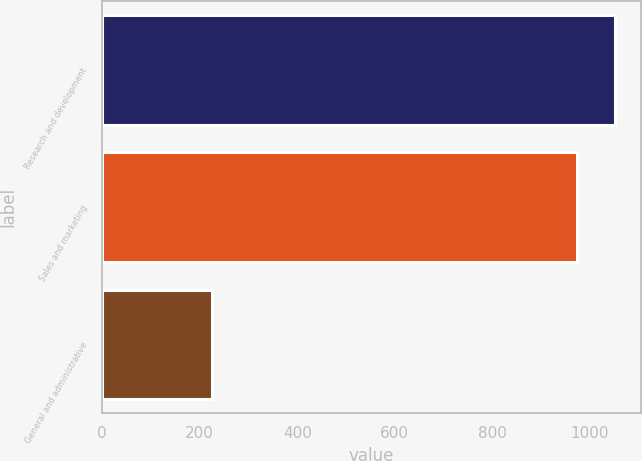Convert chart. <chart><loc_0><loc_0><loc_500><loc_500><bar_chart><fcel>Research and development<fcel>Sales and marketing<fcel>General and administrative<nl><fcel>1051.78<fcel>972.9<fcel>224.9<nl></chart> 